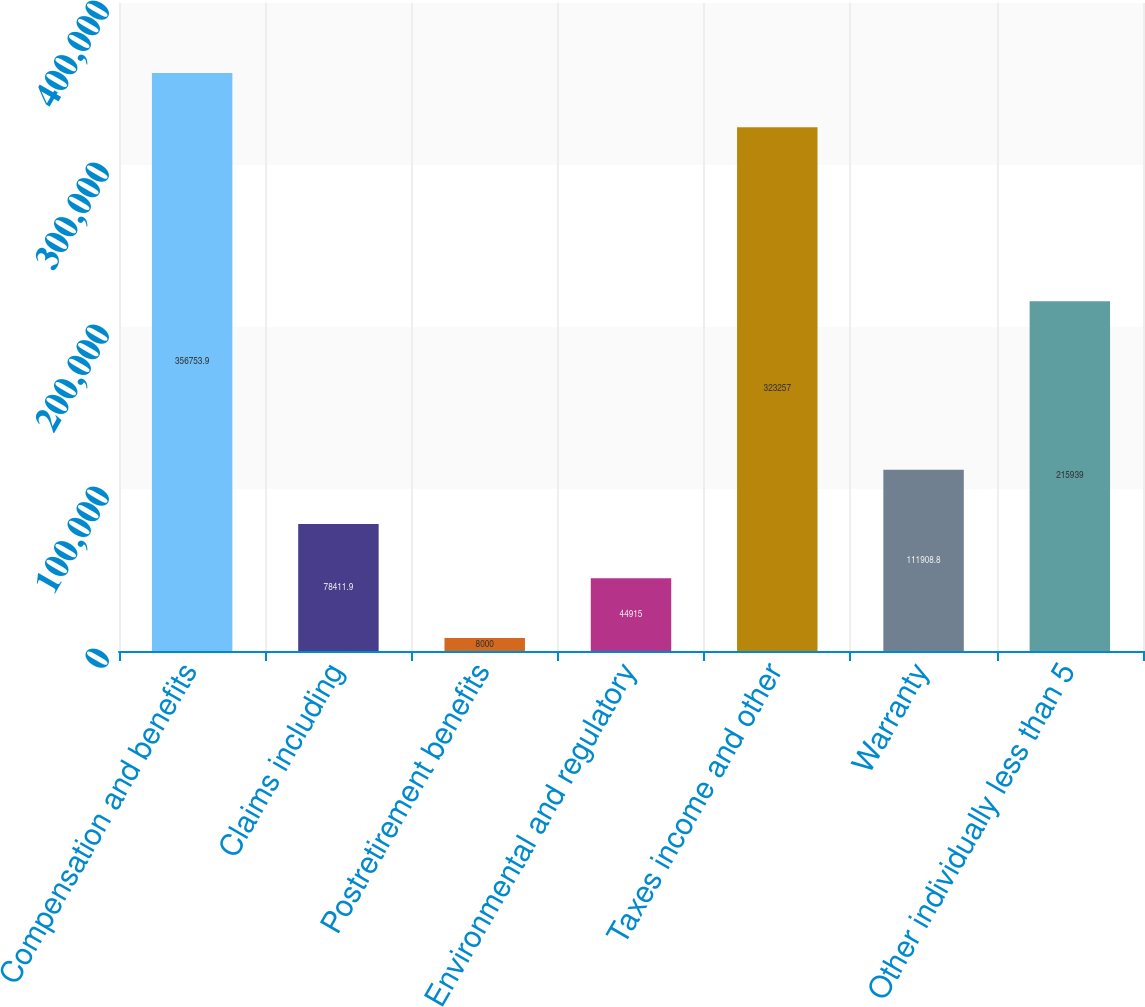Convert chart to OTSL. <chart><loc_0><loc_0><loc_500><loc_500><bar_chart><fcel>Compensation and benefits<fcel>Claims including<fcel>Postretirement benefits<fcel>Environmental and regulatory<fcel>Taxes income and other<fcel>Warranty<fcel>Other individually less than 5<nl><fcel>356754<fcel>78411.9<fcel>8000<fcel>44915<fcel>323257<fcel>111909<fcel>215939<nl></chart> 